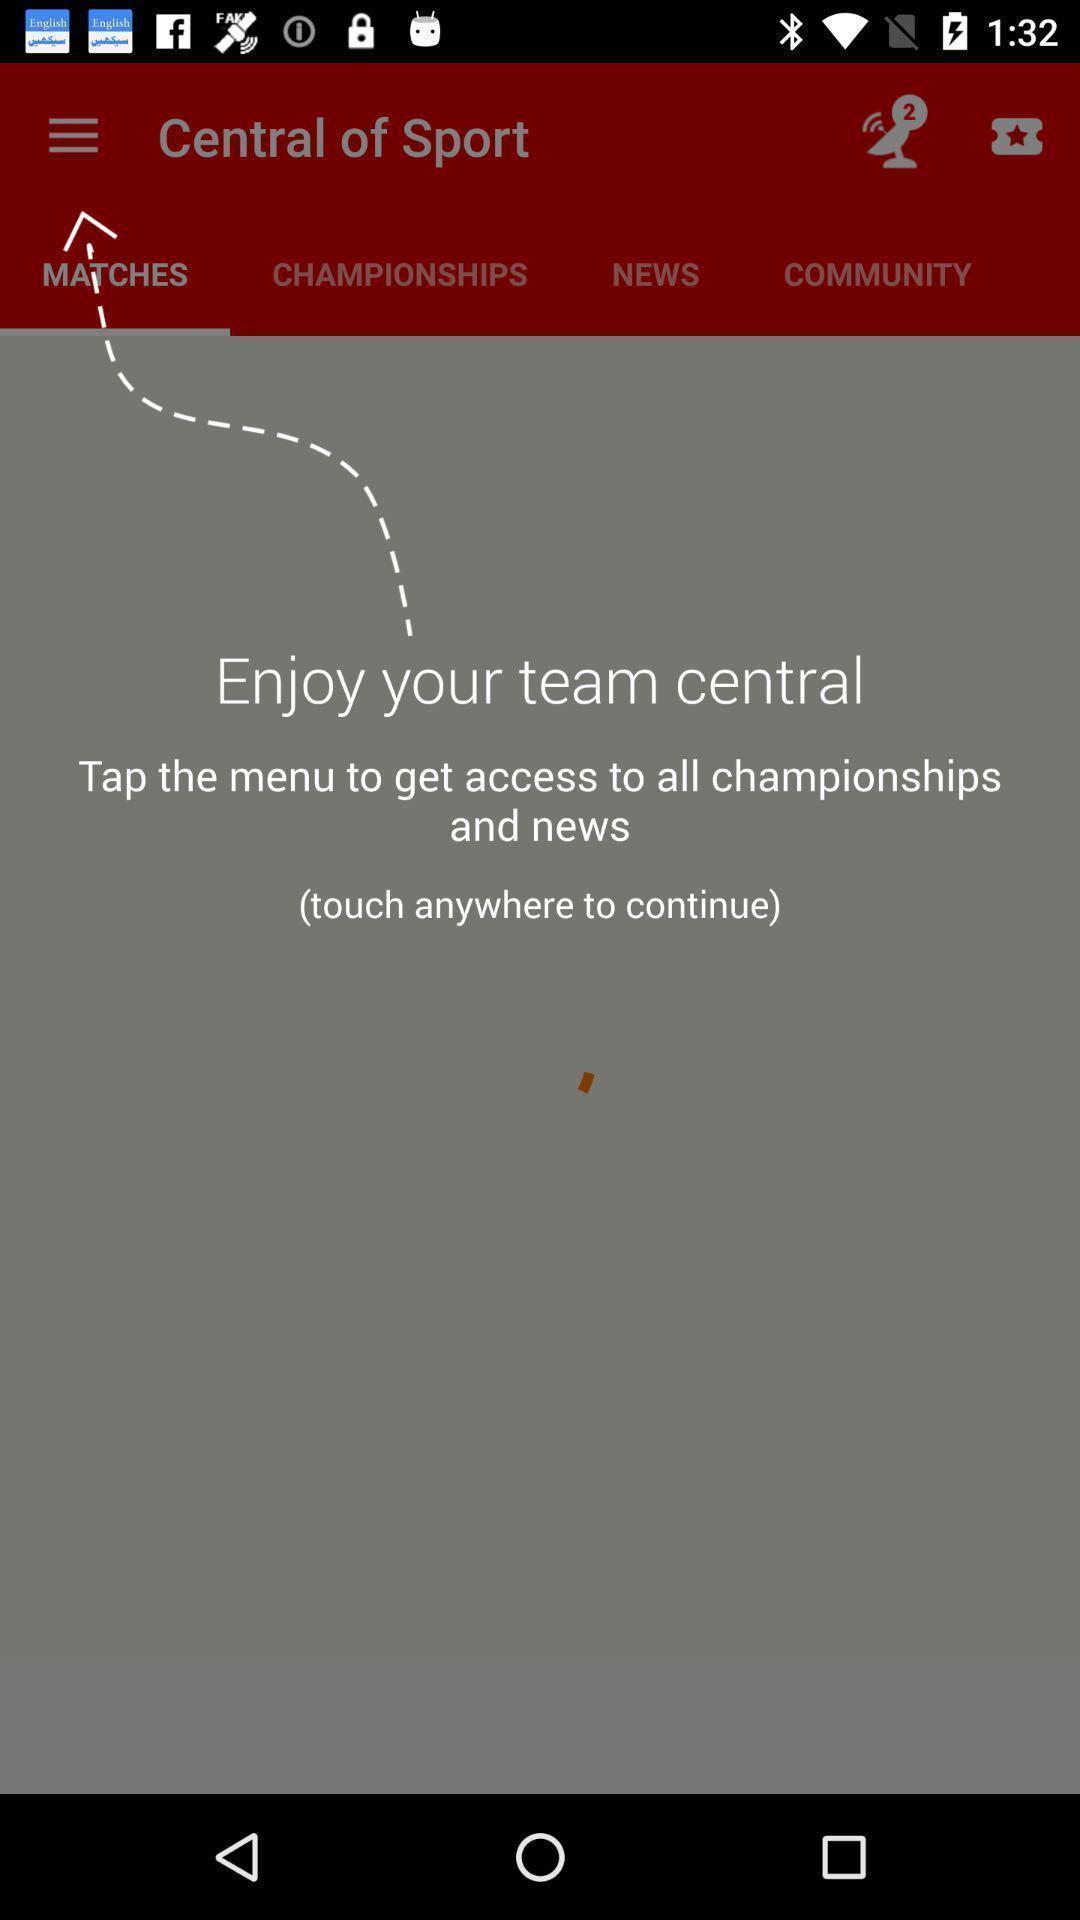What details can you identify in this image? Screen page displaying various options in sports application. 